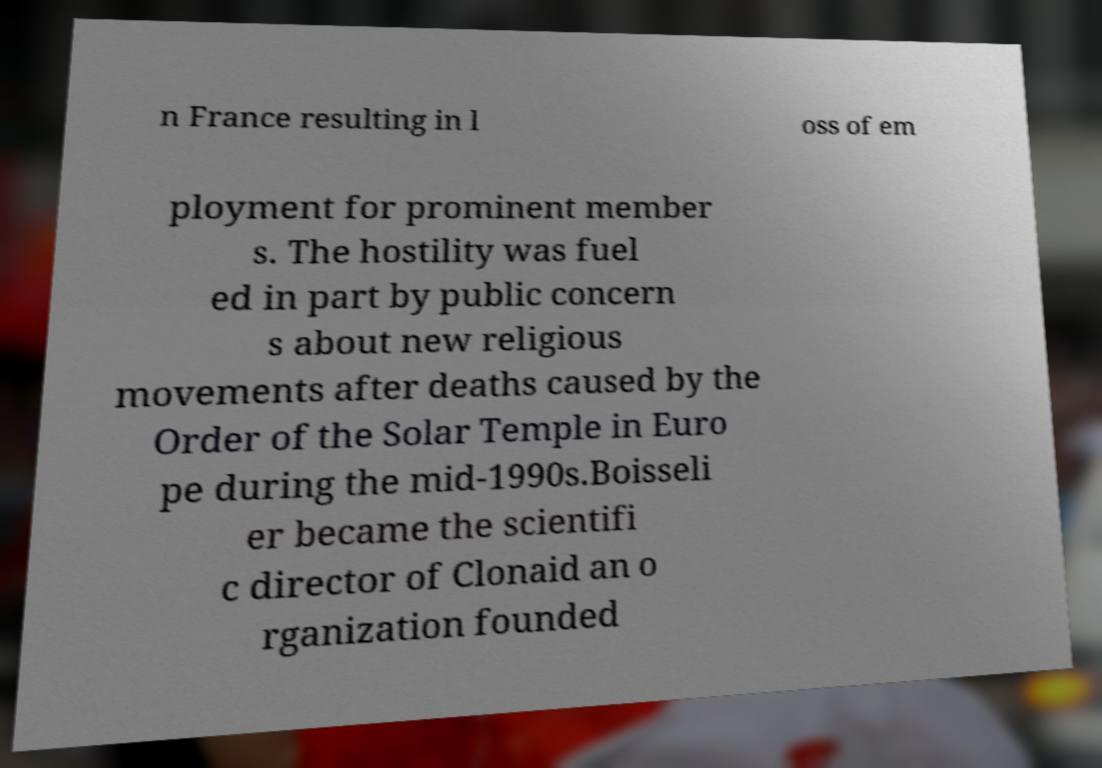Could you extract and type out the text from this image? n France resulting in l oss of em ployment for prominent member s. The hostility was fuel ed in part by public concern s about new religious movements after deaths caused by the Order of the Solar Temple in Euro pe during the mid-1990s.Boisseli er became the scientifi c director of Clonaid an o rganization founded 